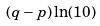<formula> <loc_0><loc_0><loc_500><loc_500>( q - p ) \ln ( 1 0 )</formula> 